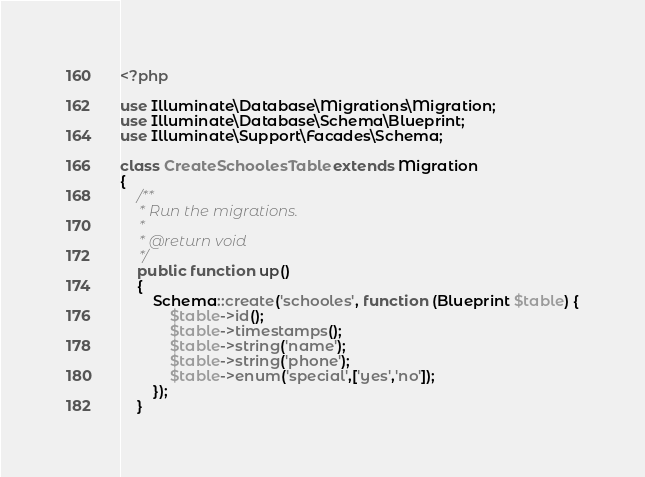Convert code to text. <code><loc_0><loc_0><loc_500><loc_500><_PHP_><?php

use Illuminate\Database\Migrations\Migration;
use Illuminate\Database\Schema\Blueprint;
use Illuminate\Support\Facades\Schema;

class CreateSchoolesTable extends Migration
{
    /**
     * Run the migrations.
     *
     * @return void
     */
    public function up()
    {
        Schema::create('schooles', function (Blueprint $table) {
            $table->id();
            $table->timestamps();
            $table->string('name');
            $table->string('phone');
            $table->enum('special',['yes','no']);
        });
    }
</code> 